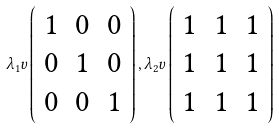<formula> <loc_0><loc_0><loc_500><loc_500>\lambda _ { 1 } v \left ( \begin{array} { c c c } 1 & 0 & 0 \\ 0 & 1 & 0 \\ 0 & 0 & 1 \end{array} \right ) , \lambda _ { 2 } v \left ( \begin{array} { c c c } 1 & 1 & 1 \\ 1 & 1 & 1 \\ 1 & 1 & 1 \end{array} \right )</formula> 